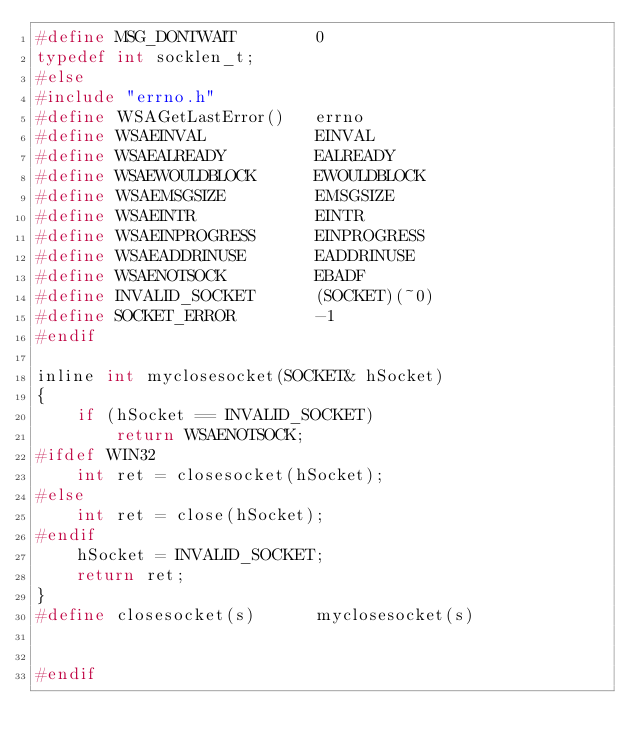Convert code to text. <code><loc_0><loc_0><loc_500><loc_500><_C_>#define MSG_DONTWAIT        0
typedef int socklen_t;
#else
#include "errno.h"
#define WSAGetLastError()   errno
#define WSAEINVAL           EINVAL
#define WSAEALREADY         EALREADY
#define WSAEWOULDBLOCK      EWOULDBLOCK
#define WSAEMSGSIZE         EMSGSIZE
#define WSAEINTR            EINTR
#define WSAEINPROGRESS      EINPROGRESS
#define WSAEADDRINUSE       EADDRINUSE
#define WSAENOTSOCK         EBADF
#define INVALID_SOCKET      (SOCKET)(~0)
#define SOCKET_ERROR        -1
#endif

inline int myclosesocket(SOCKET& hSocket)
{
    if (hSocket == INVALID_SOCKET)
        return WSAENOTSOCK;
#ifdef WIN32
    int ret = closesocket(hSocket);
#else
    int ret = close(hSocket);
#endif
    hSocket = INVALID_SOCKET;
    return ret;
}
#define closesocket(s)      myclosesocket(s)


#endif
</code> 